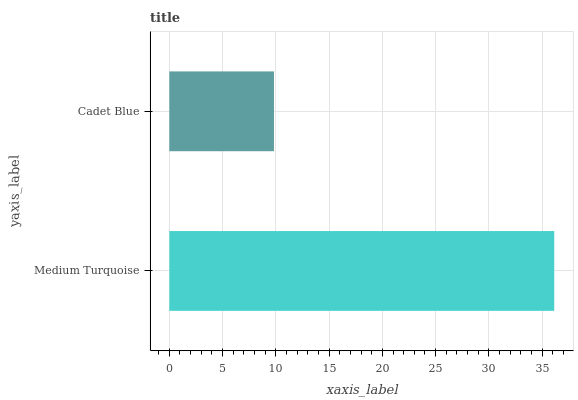Is Cadet Blue the minimum?
Answer yes or no. Yes. Is Medium Turquoise the maximum?
Answer yes or no. Yes. Is Cadet Blue the maximum?
Answer yes or no. No. Is Medium Turquoise greater than Cadet Blue?
Answer yes or no. Yes. Is Cadet Blue less than Medium Turquoise?
Answer yes or no. Yes. Is Cadet Blue greater than Medium Turquoise?
Answer yes or no. No. Is Medium Turquoise less than Cadet Blue?
Answer yes or no. No. Is Medium Turquoise the high median?
Answer yes or no. Yes. Is Cadet Blue the low median?
Answer yes or no. Yes. Is Cadet Blue the high median?
Answer yes or no. No. Is Medium Turquoise the low median?
Answer yes or no. No. 